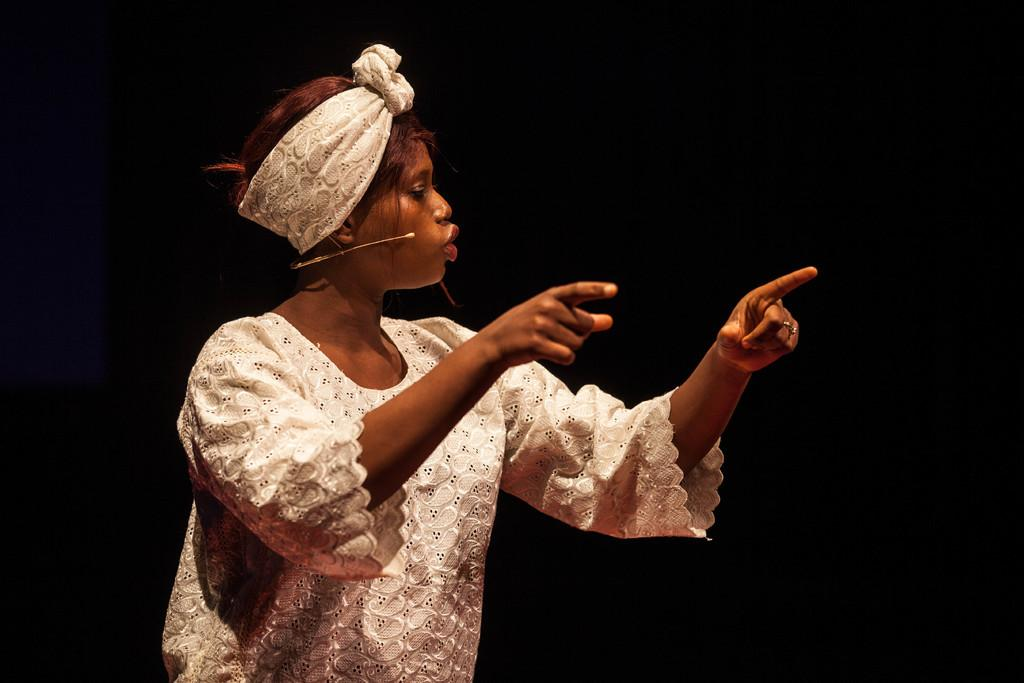What is the main subject of the image? There is a lady standing in the center of the image. What is the lady wearing? The lady is wearing a white dress. Can you identify any objects in the image? Yes, there is a mic visible in the image. How much oil is being drained from the lady's dress in the image? There is no oil or drain present in the image, and the lady's dress is not being drained of anything. 